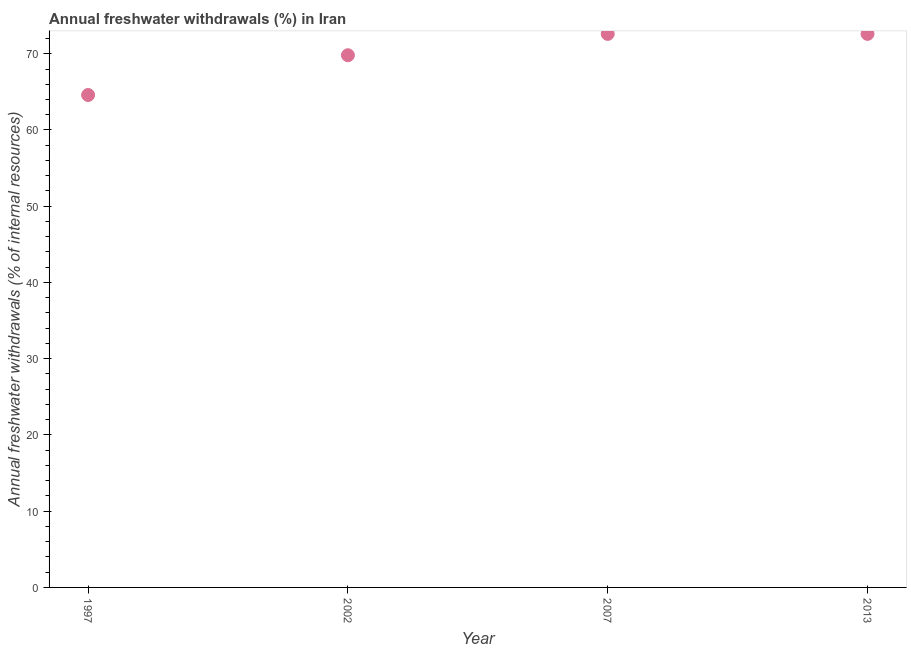What is the annual freshwater withdrawals in 2007?
Keep it short and to the point. 72.61. Across all years, what is the maximum annual freshwater withdrawals?
Give a very brief answer. 72.61. Across all years, what is the minimum annual freshwater withdrawals?
Give a very brief answer. 64.59. In which year was the annual freshwater withdrawals minimum?
Offer a very short reply. 1997. What is the sum of the annual freshwater withdrawals?
Keep it short and to the point. 279.61. What is the difference between the annual freshwater withdrawals in 1997 and 2002?
Give a very brief answer. -5.21. What is the average annual freshwater withdrawals per year?
Offer a terse response. 69.9. What is the median annual freshwater withdrawals?
Your response must be concise. 71.21. In how many years, is the annual freshwater withdrawals greater than 2 %?
Your response must be concise. 4. What is the ratio of the annual freshwater withdrawals in 2002 to that in 2007?
Offer a terse response. 0.96. Is the annual freshwater withdrawals in 2002 less than that in 2013?
Your answer should be very brief. Yes. Is the difference between the annual freshwater withdrawals in 1997 and 2007 greater than the difference between any two years?
Your answer should be compact. Yes. What is the difference between the highest and the second highest annual freshwater withdrawals?
Offer a terse response. 0. Is the sum of the annual freshwater withdrawals in 1997 and 2007 greater than the maximum annual freshwater withdrawals across all years?
Provide a short and direct response. Yes. What is the difference between the highest and the lowest annual freshwater withdrawals?
Make the answer very short. 8.02. In how many years, is the annual freshwater withdrawals greater than the average annual freshwater withdrawals taken over all years?
Your answer should be compact. 2. How many dotlines are there?
Your answer should be very brief. 1. How many years are there in the graph?
Provide a short and direct response. 4. What is the title of the graph?
Your answer should be compact. Annual freshwater withdrawals (%) in Iran. What is the label or title of the X-axis?
Keep it short and to the point. Year. What is the label or title of the Y-axis?
Provide a succinct answer. Annual freshwater withdrawals (% of internal resources). What is the Annual freshwater withdrawals (% of internal resources) in 1997?
Give a very brief answer. 64.59. What is the Annual freshwater withdrawals (% of internal resources) in 2002?
Offer a very short reply. 69.81. What is the Annual freshwater withdrawals (% of internal resources) in 2007?
Your answer should be very brief. 72.61. What is the Annual freshwater withdrawals (% of internal resources) in 2013?
Provide a short and direct response. 72.61. What is the difference between the Annual freshwater withdrawals (% of internal resources) in 1997 and 2002?
Offer a very short reply. -5.21. What is the difference between the Annual freshwater withdrawals (% of internal resources) in 1997 and 2007?
Your answer should be compact. -8.02. What is the difference between the Annual freshwater withdrawals (% of internal resources) in 1997 and 2013?
Give a very brief answer. -8.02. What is the difference between the Annual freshwater withdrawals (% of internal resources) in 2002 and 2007?
Offer a very short reply. -2.8. What is the difference between the Annual freshwater withdrawals (% of internal resources) in 2002 and 2013?
Your answer should be very brief. -2.8. What is the difference between the Annual freshwater withdrawals (% of internal resources) in 2007 and 2013?
Your answer should be compact. 0. What is the ratio of the Annual freshwater withdrawals (% of internal resources) in 1997 to that in 2002?
Your answer should be very brief. 0.93. What is the ratio of the Annual freshwater withdrawals (% of internal resources) in 1997 to that in 2007?
Your answer should be very brief. 0.89. What is the ratio of the Annual freshwater withdrawals (% of internal resources) in 1997 to that in 2013?
Your response must be concise. 0.89. What is the ratio of the Annual freshwater withdrawals (% of internal resources) in 2002 to that in 2013?
Your response must be concise. 0.96. What is the ratio of the Annual freshwater withdrawals (% of internal resources) in 2007 to that in 2013?
Provide a short and direct response. 1. 